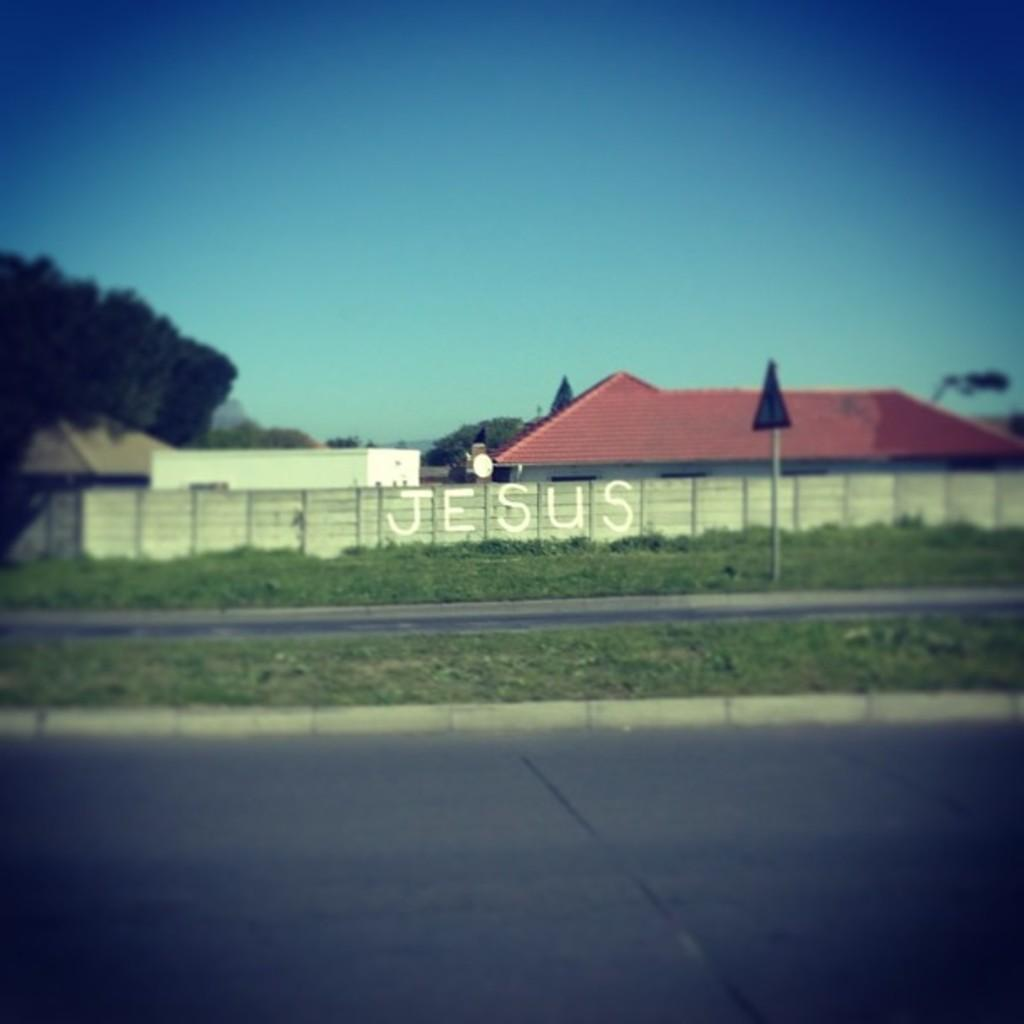What type of structures can be seen in the image? There are houses in the image. What natural elements are present in the image? There are trees and plants in the image. What man-made structures can be seen in the image? There are walls, roads, a pole, and a board in the image. What part of the natural environment is visible in the image? The sky is visible in the image. Is there any text visible in the image? Yes, there is some text visible in the image. What type of jam is being protested against in the image? There is no protest or jam present in the image. What suggestion is being made on the board in the image? There is no suggestion visible on the board in the image. 